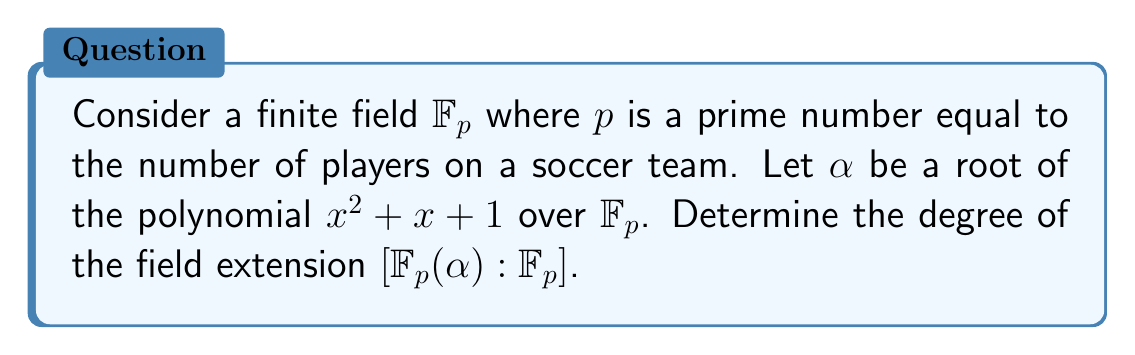Give your solution to this math problem. Let's approach this step-by-step:

1) First, we need to identify the value of $p$. In soccer, there are 11 players on a team. So, $p = 11$.

2) Now, we're dealing with the finite field $\mathbb{F}_{11}$.

3) We need to determine if the polynomial $f(x) = x^2 + x + 1$ is irreducible over $\mathbb{F}_{11}$.

4) To do this, we can check if $f(x)$ has any roots in $\mathbb{F}_{11}$. If it doesn't, then it's irreducible.

5) Let's evaluate $f(x)$ for all elements of $\mathbb{F}_{11}$:

   $f(0) = 1$
   $f(1) = 3$
   $f(2) = 7$
   $f(3) = 2$
   $f(4) = 9$
   $f(5) = 7$
   $f(6) = 7$
   $f(7) = 9$
   $f(8) = 2$
   $f(9) = 7$
   $f(10) = 3$

6) We can see that $f(x)$ has no roots in $\mathbb{F}_{11}$, so it's irreducible over $\mathbb{F}_{11}$.

7) The degree of an irreducible polynomial is equal to the degree of the field extension it generates.

8) The polynomial $f(x)$ is of degree 2.

Therefore, the degree of the field extension $[\mathbb{F}_{11}(\alpha) : \mathbb{F}_{11}]$ is 2.
Answer: 2 